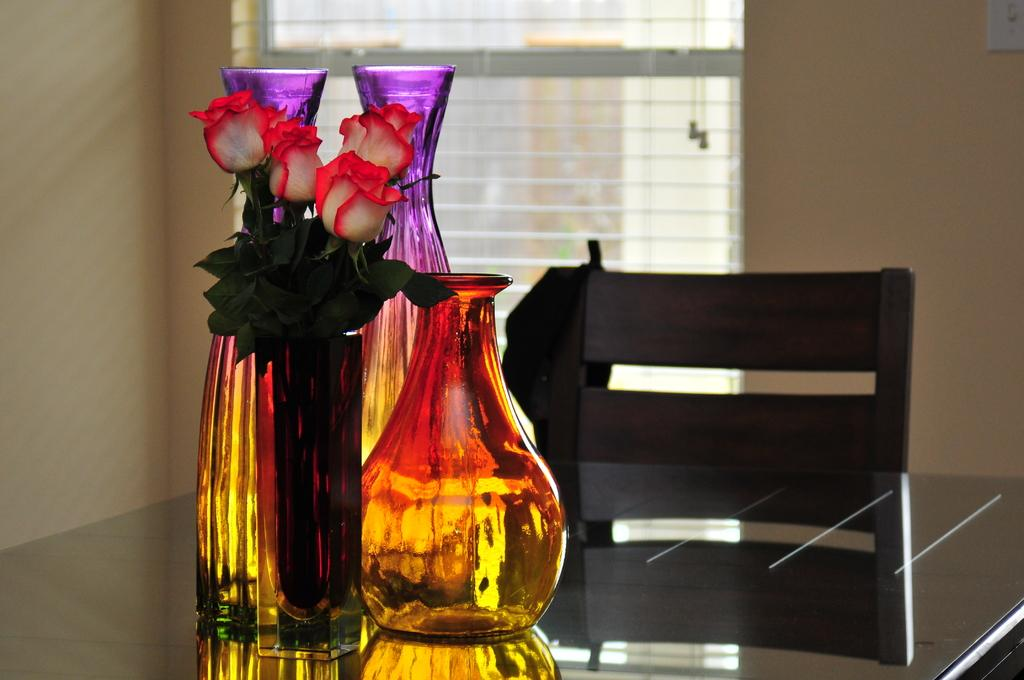What type of furniture is present in the image? There is a table in the image. What is placed on the table? There are vases on the table. Are there any flowers visible in the image? Yes, there are flowers on one of the vases. What is located near the table? There is a chair near the table. What can be seen in the background of the image? There is a wall and a window with a curtain in the background of the image. Can you compare the alley and cemetery visible in the image? There is no alley or cemetery present in the image; it features a table with vases, flowers, a chair, and a window with a curtain in the background. 